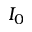Convert formula to latex. <formula><loc_0><loc_0><loc_500><loc_500>I _ { 0 }</formula> 